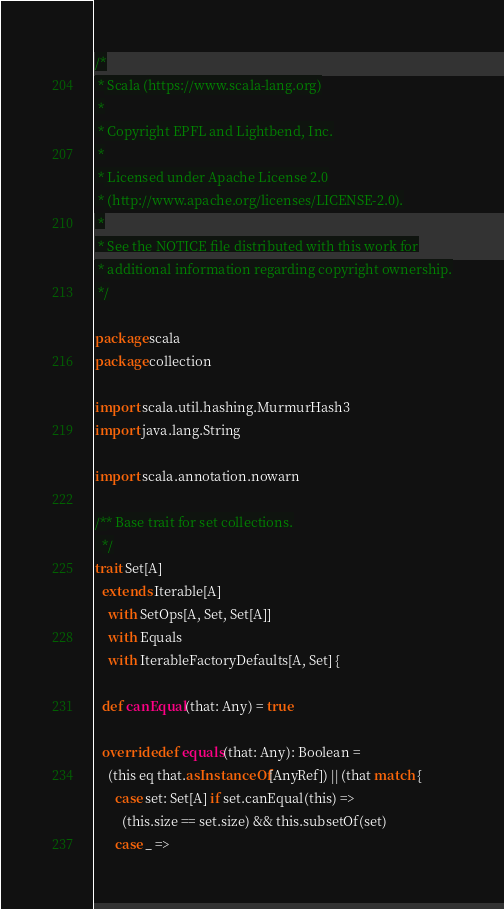Convert code to text. <code><loc_0><loc_0><loc_500><loc_500><_Scala_>/*
 * Scala (https://www.scala-lang.org)
 *
 * Copyright EPFL and Lightbend, Inc.
 *
 * Licensed under Apache License 2.0
 * (http://www.apache.org/licenses/LICENSE-2.0).
 *
 * See the NOTICE file distributed with this work for
 * additional information regarding copyright ownership.
 */

package scala
package collection

import scala.util.hashing.MurmurHash3
import java.lang.String

import scala.annotation.nowarn

/** Base trait for set collections.
  */
trait Set[A]
  extends Iterable[A]
    with SetOps[A, Set, Set[A]]
    with Equals
    with IterableFactoryDefaults[A, Set] {

  def canEqual(that: Any) = true

  override def equals(that: Any): Boolean =
    (this eq that.asInstanceOf[AnyRef]) || (that match {
      case set: Set[A] if set.canEqual(this) =>
        (this.size == set.size) && this.subsetOf(set)
      case _ =></code> 